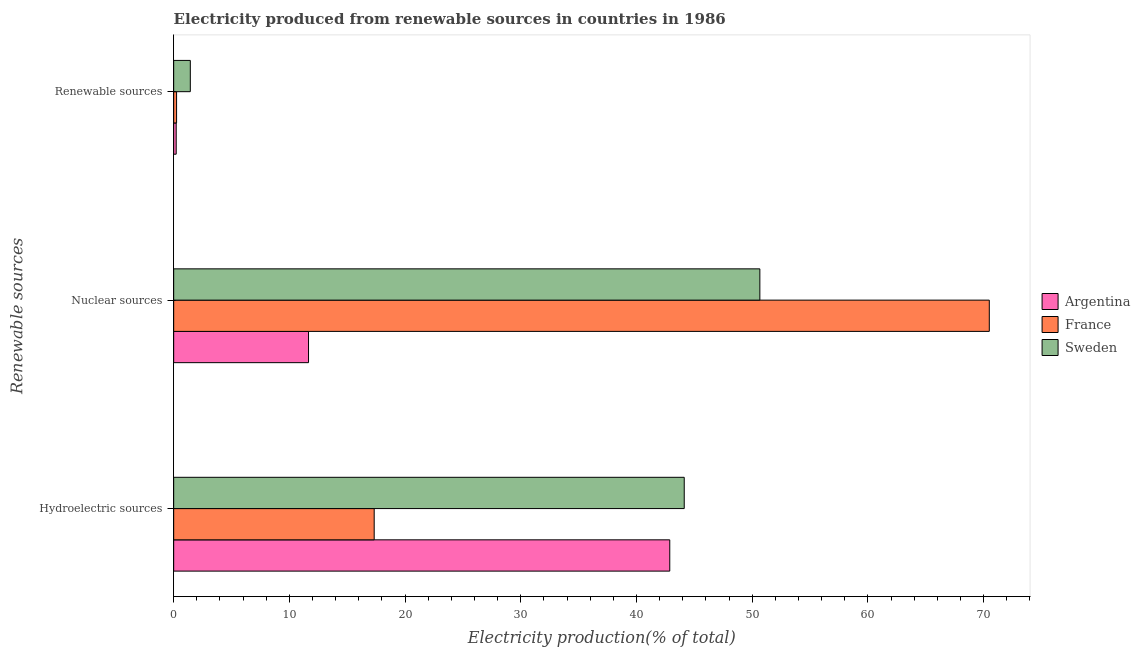How many groups of bars are there?
Offer a terse response. 3. Are the number of bars on each tick of the Y-axis equal?
Provide a short and direct response. Yes. How many bars are there on the 1st tick from the bottom?
Give a very brief answer. 3. What is the label of the 2nd group of bars from the top?
Give a very brief answer. Nuclear sources. What is the percentage of electricity produced by renewable sources in France?
Your answer should be compact. 0.25. Across all countries, what is the maximum percentage of electricity produced by nuclear sources?
Give a very brief answer. 70.49. Across all countries, what is the minimum percentage of electricity produced by renewable sources?
Offer a terse response. 0.22. In which country was the percentage of electricity produced by renewable sources maximum?
Provide a succinct answer. Sweden. What is the total percentage of electricity produced by hydroelectric sources in the graph?
Ensure brevity in your answer.  104.32. What is the difference between the percentage of electricity produced by renewable sources in Sweden and that in Argentina?
Give a very brief answer. 1.22. What is the difference between the percentage of electricity produced by nuclear sources in France and the percentage of electricity produced by hydroelectric sources in Argentina?
Offer a terse response. 27.61. What is the average percentage of electricity produced by renewable sources per country?
Offer a very short reply. 0.64. What is the difference between the percentage of electricity produced by renewable sources and percentage of electricity produced by hydroelectric sources in Sweden?
Ensure brevity in your answer.  -42.68. What is the ratio of the percentage of electricity produced by renewable sources in Sweden to that in France?
Keep it short and to the point. 5.72. Is the difference between the percentage of electricity produced by renewable sources in France and Sweden greater than the difference between the percentage of electricity produced by hydroelectric sources in France and Sweden?
Your response must be concise. Yes. What is the difference between the highest and the second highest percentage of electricity produced by nuclear sources?
Make the answer very short. 19.83. What is the difference between the highest and the lowest percentage of electricity produced by nuclear sources?
Your response must be concise. 58.83. Is the sum of the percentage of electricity produced by renewable sources in Argentina and Sweden greater than the maximum percentage of electricity produced by hydroelectric sources across all countries?
Offer a terse response. No. What does the 1st bar from the bottom in Nuclear sources represents?
Offer a very short reply. Argentina. Is it the case that in every country, the sum of the percentage of electricity produced by hydroelectric sources and percentage of electricity produced by nuclear sources is greater than the percentage of electricity produced by renewable sources?
Give a very brief answer. Yes. How many bars are there?
Make the answer very short. 9. Are all the bars in the graph horizontal?
Provide a short and direct response. Yes. How many countries are there in the graph?
Give a very brief answer. 3. What is the difference between two consecutive major ticks on the X-axis?
Offer a very short reply. 10. Does the graph contain any zero values?
Ensure brevity in your answer.  No. How many legend labels are there?
Provide a short and direct response. 3. What is the title of the graph?
Your answer should be compact. Electricity produced from renewable sources in countries in 1986. Does "Hungary" appear as one of the legend labels in the graph?
Your answer should be very brief. No. What is the label or title of the X-axis?
Your answer should be compact. Electricity production(% of total). What is the label or title of the Y-axis?
Ensure brevity in your answer.  Renewable sources. What is the Electricity production(% of total) in Argentina in Hydroelectric sources?
Provide a succinct answer. 42.87. What is the Electricity production(% of total) in France in Hydroelectric sources?
Make the answer very short. 17.33. What is the Electricity production(% of total) in Sweden in Hydroelectric sources?
Offer a very short reply. 44.12. What is the Electricity production(% of total) of Argentina in Nuclear sources?
Ensure brevity in your answer.  11.65. What is the Electricity production(% of total) of France in Nuclear sources?
Provide a succinct answer. 70.49. What is the Electricity production(% of total) of Sweden in Nuclear sources?
Offer a terse response. 50.66. What is the Electricity production(% of total) in Argentina in Renewable sources?
Your answer should be compact. 0.22. What is the Electricity production(% of total) in France in Renewable sources?
Provide a short and direct response. 0.25. What is the Electricity production(% of total) of Sweden in Renewable sources?
Keep it short and to the point. 1.44. Across all Renewable sources, what is the maximum Electricity production(% of total) in Argentina?
Ensure brevity in your answer.  42.87. Across all Renewable sources, what is the maximum Electricity production(% of total) in France?
Give a very brief answer. 70.49. Across all Renewable sources, what is the maximum Electricity production(% of total) in Sweden?
Your response must be concise. 50.66. Across all Renewable sources, what is the minimum Electricity production(% of total) of Argentina?
Your answer should be very brief. 0.22. Across all Renewable sources, what is the minimum Electricity production(% of total) in France?
Offer a very short reply. 0.25. Across all Renewable sources, what is the minimum Electricity production(% of total) of Sweden?
Offer a terse response. 1.44. What is the total Electricity production(% of total) of Argentina in the graph?
Provide a short and direct response. 54.75. What is the total Electricity production(% of total) in France in the graph?
Give a very brief answer. 88.07. What is the total Electricity production(% of total) of Sweden in the graph?
Provide a succinct answer. 96.22. What is the difference between the Electricity production(% of total) in Argentina in Hydroelectric sources and that in Nuclear sources?
Your answer should be very brief. 31.22. What is the difference between the Electricity production(% of total) of France in Hydroelectric sources and that in Nuclear sources?
Ensure brevity in your answer.  -53.16. What is the difference between the Electricity production(% of total) in Sweden in Hydroelectric sources and that in Nuclear sources?
Provide a succinct answer. -6.54. What is the difference between the Electricity production(% of total) in Argentina in Hydroelectric sources and that in Renewable sources?
Make the answer very short. 42.65. What is the difference between the Electricity production(% of total) of France in Hydroelectric sources and that in Renewable sources?
Your answer should be compact. 17.08. What is the difference between the Electricity production(% of total) in Sweden in Hydroelectric sources and that in Renewable sources?
Offer a very short reply. 42.68. What is the difference between the Electricity production(% of total) in Argentina in Nuclear sources and that in Renewable sources?
Offer a very short reply. 11.44. What is the difference between the Electricity production(% of total) of France in Nuclear sources and that in Renewable sources?
Your answer should be very brief. 70.24. What is the difference between the Electricity production(% of total) in Sweden in Nuclear sources and that in Renewable sources?
Provide a succinct answer. 49.22. What is the difference between the Electricity production(% of total) in Argentina in Hydroelectric sources and the Electricity production(% of total) in France in Nuclear sources?
Give a very brief answer. -27.61. What is the difference between the Electricity production(% of total) of Argentina in Hydroelectric sources and the Electricity production(% of total) of Sweden in Nuclear sources?
Provide a succinct answer. -7.79. What is the difference between the Electricity production(% of total) of France in Hydroelectric sources and the Electricity production(% of total) of Sweden in Nuclear sources?
Provide a succinct answer. -33.33. What is the difference between the Electricity production(% of total) in Argentina in Hydroelectric sources and the Electricity production(% of total) in France in Renewable sources?
Your answer should be compact. 42.62. What is the difference between the Electricity production(% of total) of Argentina in Hydroelectric sources and the Electricity production(% of total) of Sweden in Renewable sources?
Provide a short and direct response. 41.43. What is the difference between the Electricity production(% of total) of France in Hydroelectric sources and the Electricity production(% of total) of Sweden in Renewable sources?
Give a very brief answer. 15.89. What is the difference between the Electricity production(% of total) of Argentina in Nuclear sources and the Electricity production(% of total) of France in Renewable sources?
Ensure brevity in your answer.  11.4. What is the difference between the Electricity production(% of total) in Argentina in Nuclear sources and the Electricity production(% of total) in Sweden in Renewable sources?
Make the answer very short. 10.22. What is the difference between the Electricity production(% of total) in France in Nuclear sources and the Electricity production(% of total) in Sweden in Renewable sources?
Make the answer very short. 69.05. What is the average Electricity production(% of total) of Argentina per Renewable sources?
Ensure brevity in your answer.  18.25. What is the average Electricity production(% of total) of France per Renewable sources?
Keep it short and to the point. 29.36. What is the average Electricity production(% of total) in Sweden per Renewable sources?
Keep it short and to the point. 32.07. What is the difference between the Electricity production(% of total) of Argentina and Electricity production(% of total) of France in Hydroelectric sources?
Keep it short and to the point. 25.54. What is the difference between the Electricity production(% of total) in Argentina and Electricity production(% of total) in Sweden in Hydroelectric sources?
Your answer should be very brief. -1.25. What is the difference between the Electricity production(% of total) of France and Electricity production(% of total) of Sweden in Hydroelectric sources?
Keep it short and to the point. -26.79. What is the difference between the Electricity production(% of total) of Argentina and Electricity production(% of total) of France in Nuclear sources?
Ensure brevity in your answer.  -58.83. What is the difference between the Electricity production(% of total) of Argentina and Electricity production(% of total) of Sweden in Nuclear sources?
Your response must be concise. -39. What is the difference between the Electricity production(% of total) of France and Electricity production(% of total) of Sweden in Nuclear sources?
Provide a succinct answer. 19.83. What is the difference between the Electricity production(% of total) of Argentina and Electricity production(% of total) of France in Renewable sources?
Keep it short and to the point. -0.03. What is the difference between the Electricity production(% of total) in Argentina and Electricity production(% of total) in Sweden in Renewable sources?
Offer a very short reply. -1.22. What is the difference between the Electricity production(% of total) in France and Electricity production(% of total) in Sweden in Renewable sources?
Provide a short and direct response. -1.19. What is the ratio of the Electricity production(% of total) of Argentina in Hydroelectric sources to that in Nuclear sources?
Give a very brief answer. 3.68. What is the ratio of the Electricity production(% of total) in France in Hydroelectric sources to that in Nuclear sources?
Make the answer very short. 0.25. What is the ratio of the Electricity production(% of total) in Sweden in Hydroelectric sources to that in Nuclear sources?
Make the answer very short. 0.87. What is the ratio of the Electricity production(% of total) in Argentina in Hydroelectric sources to that in Renewable sources?
Keep it short and to the point. 196.35. What is the ratio of the Electricity production(% of total) of France in Hydroelectric sources to that in Renewable sources?
Give a very brief answer. 68.97. What is the ratio of the Electricity production(% of total) in Sweden in Hydroelectric sources to that in Renewable sources?
Make the answer very short. 30.68. What is the ratio of the Electricity production(% of total) of Argentina in Nuclear sources to that in Renewable sources?
Make the answer very short. 53.37. What is the ratio of the Electricity production(% of total) of France in Nuclear sources to that in Renewable sources?
Make the answer very short. 280.52. What is the ratio of the Electricity production(% of total) in Sweden in Nuclear sources to that in Renewable sources?
Give a very brief answer. 35.22. What is the difference between the highest and the second highest Electricity production(% of total) of Argentina?
Give a very brief answer. 31.22. What is the difference between the highest and the second highest Electricity production(% of total) of France?
Provide a succinct answer. 53.16. What is the difference between the highest and the second highest Electricity production(% of total) of Sweden?
Ensure brevity in your answer.  6.54. What is the difference between the highest and the lowest Electricity production(% of total) of Argentina?
Provide a succinct answer. 42.65. What is the difference between the highest and the lowest Electricity production(% of total) in France?
Keep it short and to the point. 70.24. What is the difference between the highest and the lowest Electricity production(% of total) in Sweden?
Give a very brief answer. 49.22. 